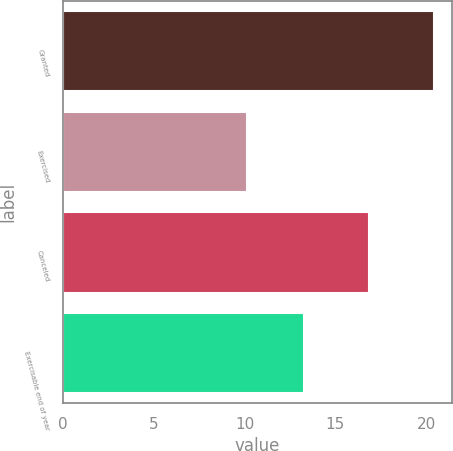<chart> <loc_0><loc_0><loc_500><loc_500><bar_chart><fcel>Granted<fcel>Exercised<fcel>Canceled<fcel>Exercisable end of year<nl><fcel>20.43<fcel>10.15<fcel>16.88<fcel>13.25<nl></chart> 